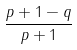Convert formula to latex. <formula><loc_0><loc_0><loc_500><loc_500>\frac { p + 1 - q } { p + 1 }</formula> 